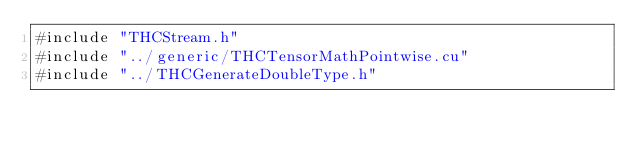Convert code to text. <code><loc_0><loc_0><loc_500><loc_500><_Cuda_>#include "THCStream.h"
#include "../generic/THCTensorMathPointwise.cu"
#include "../THCGenerateDoubleType.h"
</code> 